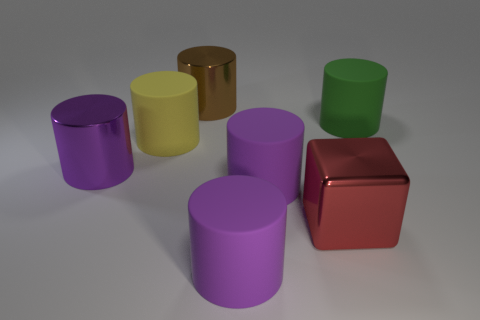What shapes can be seen in the image? The shapes present in the image include cylinders and a single cube.  Are there any shadows visible, and what can they tell us about the lighting? Yes, shadows can be observed beneath each object, indicating that the light source is positioned above the objects, likely out of the frame of the image. 